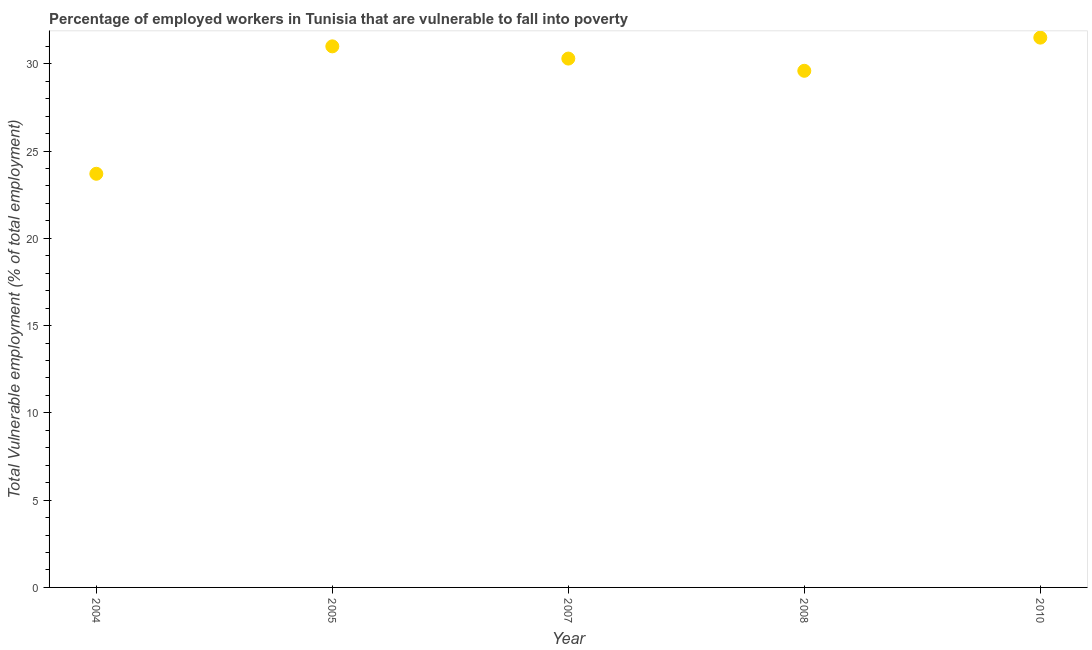Across all years, what is the maximum total vulnerable employment?
Ensure brevity in your answer.  31.5. Across all years, what is the minimum total vulnerable employment?
Offer a very short reply. 23.7. In which year was the total vulnerable employment maximum?
Keep it short and to the point. 2010. What is the sum of the total vulnerable employment?
Offer a very short reply. 146.1. What is the difference between the total vulnerable employment in 2004 and 2007?
Offer a terse response. -6.6. What is the average total vulnerable employment per year?
Offer a terse response. 29.22. What is the median total vulnerable employment?
Offer a terse response. 30.3. In how many years, is the total vulnerable employment greater than 23 %?
Provide a short and direct response. 5. What is the ratio of the total vulnerable employment in 2004 to that in 2010?
Your answer should be very brief. 0.75. Is the total vulnerable employment in 2004 less than that in 2007?
Ensure brevity in your answer.  Yes. What is the difference between the highest and the second highest total vulnerable employment?
Provide a succinct answer. 0.5. Is the sum of the total vulnerable employment in 2007 and 2010 greater than the maximum total vulnerable employment across all years?
Provide a succinct answer. Yes. What is the difference between the highest and the lowest total vulnerable employment?
Your answer should be compact. 7.8. Does the total vulnerable employment monotonically increase over the years?
Provide a succinct answer. No. Are the values on the major ticks of Y-axis written in scientific E-notation?
Give a very brief answer. No. Does the graph contain grids?
Offer a very short reply. No. What is the title of the graph?
Keep it short and to the point. Percentage of employed workers in Tunisia that are vulnerable to fall into poverty. What is the label or title of the Y-axis?
Provide a succinct answer. Total Vulnerable employment (% of total employment). What is the Total Vulnerable employment (% of total employment) in 2004?
Provide a succinct answer. 23.7. What is the Total Vulnerable employment (% of total employment) in 2007?
Provide a succinct answer. 30.3. What is the Total Vulnerable employment (% of total employment) in 2008?
Provide a short and direct response. 29.6. What is the Total Vulnerable employment (% of total employment) in 2010?
Make the answer very short. 31.5. What is the difference between the Total Vulnerable employment (% of total employment) in 2004 and 2005?
Keep it short and to the point. -7.3. What is the difference between the Total Vulnerable employment (% of total employment) in 2004 and 2007?
Make the answer very short. -6.6. What is the difference between the Total Vulnerable employment (% of total employment) in 2004 and 2008?
Offer a terse response. -5.9. What is the difference between the Total Vulnerable employment (% of total employment) in 2005 and 2010?
Make the answer very short. -0.5. What is the difference between the Total Vulnerable employment (% of total employment) in 2007 and 2010?
Your response must be concise. -1.2. What is the difference between the Total Vulnerable employment (% of total employment) in 2008 and 2010?
Keep it short and to the point. -1.9. What is the ratio of the Total Vulnerable employment (% of total employment) in 2004 to that in 2005?
Your answer should be compact. 0.77. What is the ratio of the Total Vulnerable employment (% of total employment) in 2004 to that in 2007?
Give a very brief answer. 0.78. What is the ratio of the Total Vulnerable employment (% of total employment) in 2004 to that in 2008?
Provide a succinct answer. 0.8. What is the ratio of the Total Vulnerable employment (% of total employment) in 2004 to that in 2010?
Provide a short and direct response. 0.75. What is the ratio of the Total Vulnerable employment (% of total employment) in 2005 to that in 2008?
Ensure brevity in your answer.  1.05. 